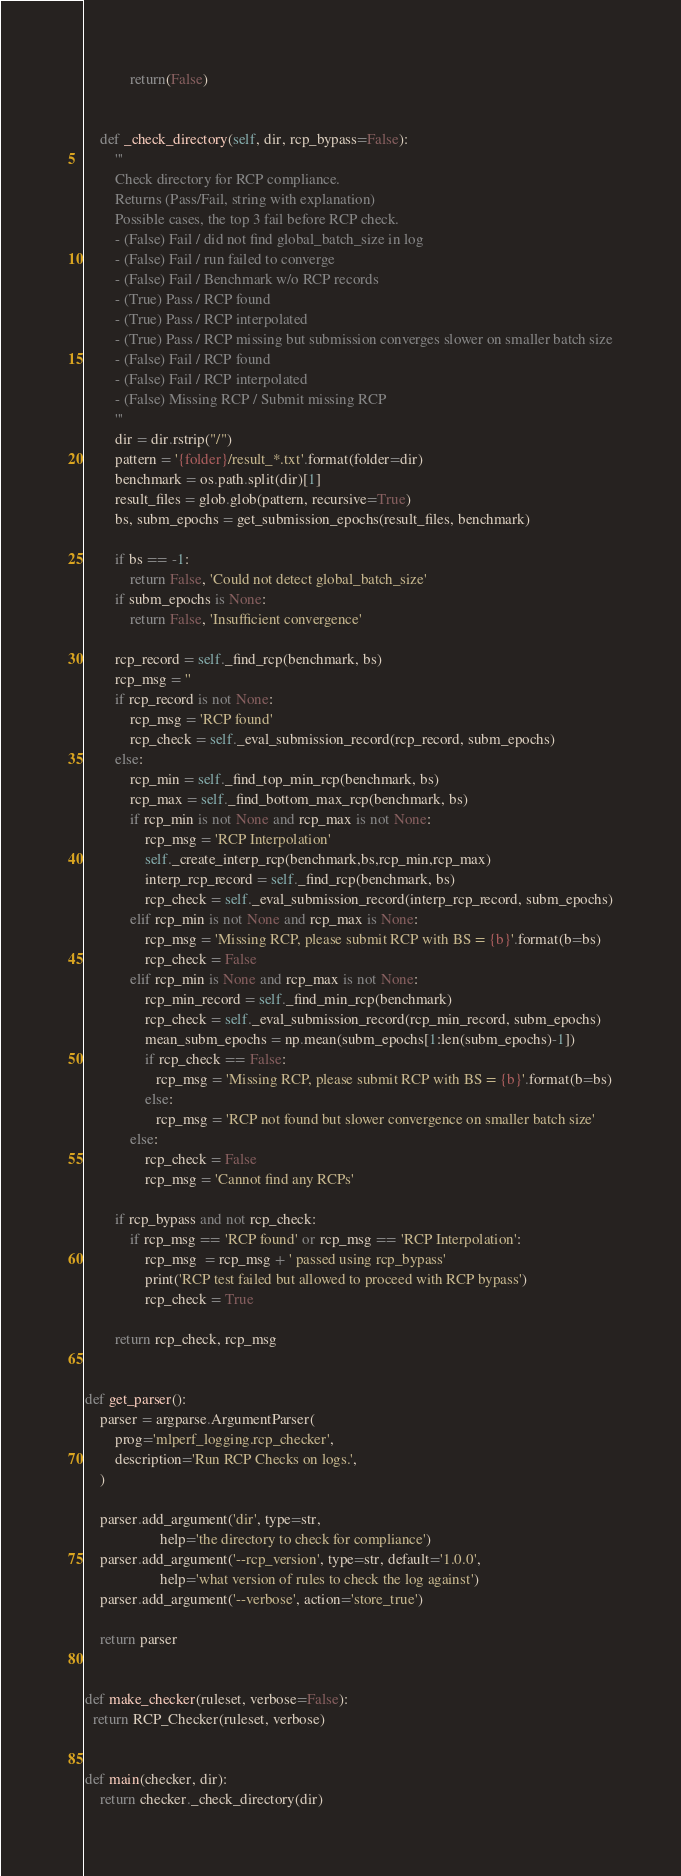<code> <loc_0><loc_0><loc_500><loc_500><_Python_>            return(False)


    def _check_directory(self, dir, rcp_bypass=False):
        '''
        Check directory for RCP compliance.
        Returns (Pass/Fail, string with explanation)
        Possible cases, the top 3 fail before RCP check.
        - (False) Fail / did not find global_batch_size in log
        - (False) Fail / run failed to converge
        - (False) Fail / Benchmark w/o RCP records
        - (True) Pass / RCP found
        - (True) Pass / RCP interpolated
        - (True) Pass / RCP missing but submission converges slower on smaller batch size
        - (False) Fail / RCP found
        - (False) Fail / RCP interpolated
        - (False) Missing RCP / Submit missing RCP
        '''
        dir = dir.rstrip("/")
        pattern = '{folder}/result_*.txt'.format(folder=dir)
        benchmark = os.path.split(dir)[1]
        result_files = glob.glob(pattern, recursive=True)
        bs, subm_epochs = get_submission_epochs(result_files, benchmark)

        if bs == -1:
            return False, 'Could not detect global_batch_size'
        if subm_epochs is None:
            return False, 'Insufficient convergence'

        rcp_record = self._find_rcp(benchmark, bs)
        rcp_msg = ''
        if rcp_record is not None:
            rcp_msg = 'RCP found'
            rcp_check = self._eval_submission_record(rcp_record, subm_epochs)
        else:
            rcp_min = self._find_top_min_rcp(benchmark, bs)
            rcp_max = self._find_bottom_max_rcp(benchmark, bs)
            if rcp_min is not None and rcp_max is not None:
                rcp_msg = 'RCP Interpolation'
                self._create_interp_rcp(benchmark,bs,rcp_min,rcp_max)
                interp_rcp_record = self._find_rcp(benchmark, bs)
                rcp_check = self._eval_submission_record(interp_rcp_record, subm_epochs)
            elif rcp_min is not None and rcp_max is None:
                rcp_msg = 'Missing RCP, please submit RCP with BS = {b}'.format(b=bs)
                rcp_check = False
            elif rcp_min is None and rcp_max is not None:
                rcp_min_record = self._find_min_rcp(benchmark)
                rcp_check = self._eval_submission_record(rcp_min_record, subm_epochs)
                mean_subm_epochs = np.mean(subm_epochs[1:len(subm_epochs)-1])
                if rcp_check == False:
                   rcp_msg = 'Missing RCP, please submit RCP with BS = {b}'.format(b=bs)
                else:
                   rcp_msg = 'RCP not found but slower convergence on smaller batch size'
            else:
                rcp_check = False
                rcp_msg = 'Cannot find any RCPs'

        if rcp_bypass and not rcp_check:
            if rcp_msg == 'RCP found' or rcp_msg == 'RCP Interpolation':
                rcp_msg  = rcp_msg + ' passed using rcp_bypass'
                print('RCP test failed but allowed to proceed with RCP bypass')
                rcp_check = True

        return rcp_check, rcp_msg


def get_parser():
    parser = argparse.ArgumentParser(
        prog='mlperf_logging.rcp_checker',
        description='Run RCP Checks on logs.',
    )

    parser.add_argument('dir', type=str,
                    help='the directory to check for compliance')
    parser.add_argument('--rcp_version', type=str, default='1.0.0',
                    help='what version of rules to check the log against')
    parser.add_argument('--verbose', action='store_true')

    return parser


def make_checker(ruleset, verbose=False):
  return RCP_Checker(ruleset, verbose)


def main(checker, dir):
    return checker._check_directory(dir)
</code> 